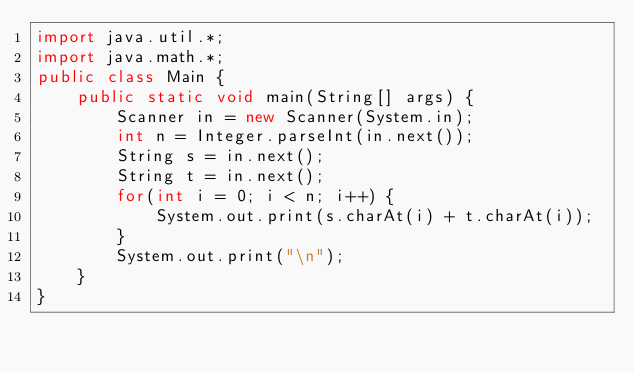<code> <loc_0><loc_0><loc_500><loc_500><_Java_>import java.util.*;
import java.math.*;
public class Main {
	public static void main(String[] args) {
		Scanner in = new Scanner(System.in);
		int n = Integer.parseInt(in.next());
		String s = in.next();
		String t = in.next();
		for(int i = 0; i < n; i++) {
			System.out.print(s.charAt(i) + t.charAt(i));
		}
		System.out.print("\n");
	}
}</code> 